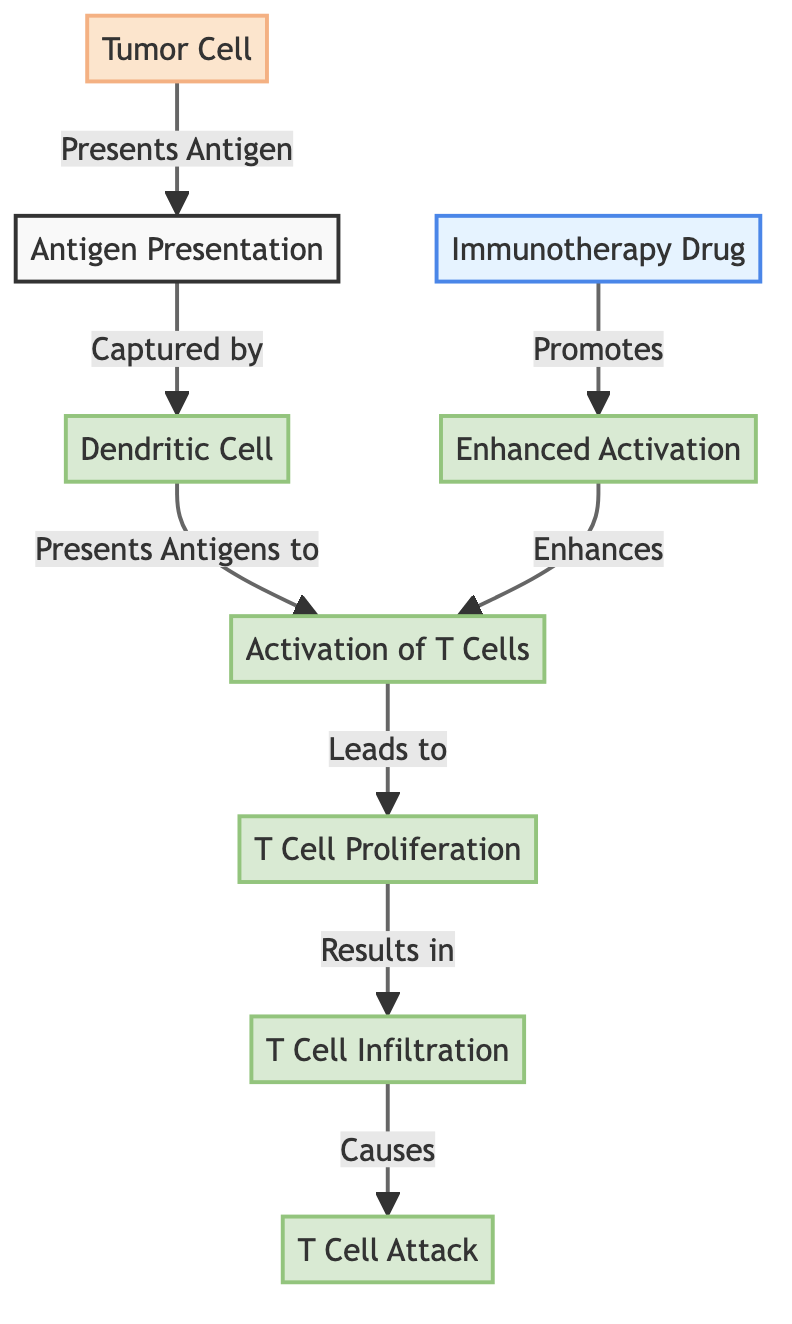what is the first step in the diagram? The first step in the diagram is "Tumor Cell," which initiates the entire process by presenting an antigen. From there, the flow moves to antigen presentation.
Answer: Tumor Cell what does the dendritic cell do in this process? The dendritic cell captures the antigen and presents it to activate the T cells. This is a crucial step in triggering the immune response against the tumor.
Answer: Presents Antigens to how many nodes are involved in T cell activation? The process of T cell activation involves three nodes: activation, T cell proliferation, and T cell infiltration. Each step builds on the previous one to enhance the immune response.
Answer: Three what effect does the immunotherapy drug have in the diagram? The immunotherapy drug promotes enhanced activation, which in turn enhances T cell activation and the overall immune response against the tumor.
Answer: Promotes describe the relationship between T cell infiltration and T cell attack? T cell infiltration directly leads to T cell attack. After T cells infiltrate the tumor, they execute the attack on the tumor cells, completing the immune response initiated by the process.
Answer: Causes what role does enhanced activation play in the mechanism? Enhanced activation strengthens the initial activation of T cells, making their response to the tumor more effective. This step emphasizes the importance of the immunotherapy drug in aiding the immune system.
Answer: Enhances 